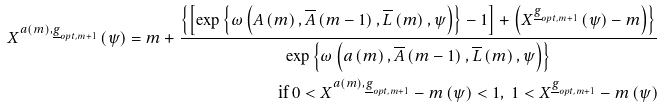<formula> <loc_0><loc_0><loc_500><loc_500>X ^ { a \left ( m \right ) , \underline { g } _ { o p t , m + 1 } } \left ( \psi \right ) = m + \frac { \left \{ \left [ \exp \left \{ \omega \left ( A \left ( m \right ) , \overline { A } \left ( m - 1 \right ) , \overline { L } \left ( m \right ) , \psi \right ) \right \} - 1 \right ] + \left ( X ^ { \underline { g } _ { o p t , m + 1 } } \left ( \psi \right ) - m \right ) \right \} } { \exp \left \{ \omega \left ( a \left ( m \right ) , \overline { A } \left ( m - 1 \right ) , \overline { L } \left ( m \right ) , \psi \right ) \right \} } \\ \text { if } 0 < X ^ { a \left ( m \right ) , \underline { g } _ { o p t , m + 1 } } - m \left ( \psi \right ) < 1 , \text { } 1 < X ^ { \underline { g } _ { o p t , m + 1 } } - m \left ( \psi \right )</formula> 